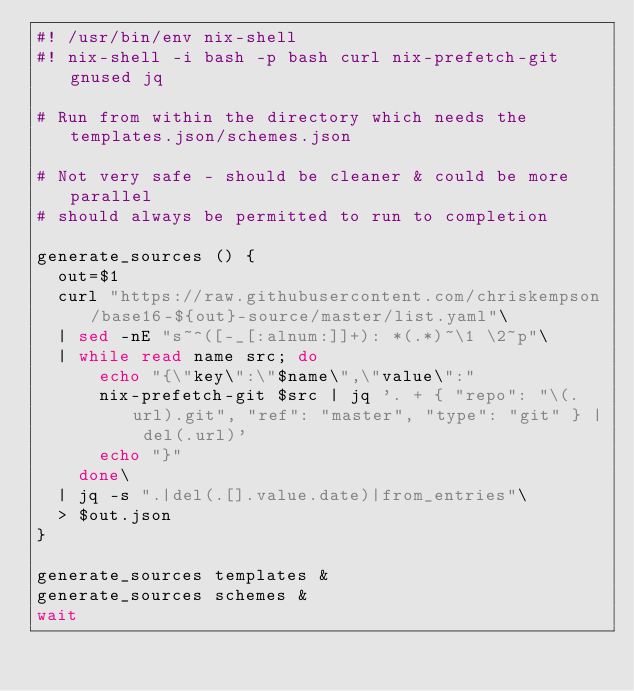Convert code to text. <code><loc_0><loc_0><loc_500><loc_500><_Bash_>#! /usr/bin/env nix-shell
#! nix-shell -i bash -p bash curl nix-prefetch-git gnused jq

# Run from within the directory which needs the templates.json/schemes.json

# Not very safe - should be cleaner & could be more parallel
# should always be permitted to run to completion

generate_sources () {
  out=$1
  curl "https://raw.githubusercontent.com/chriskempson/base16-${out}-source/master/list.yaml"\
  | sed -nE "s~^([-_[:alnum:]]+): *(.*)~\1 \2~p"\
  | while read name src; do
      echo "{\"key\":\"$name\",\"value\":"
      nix-prefetch-git $src | jq '. + { "repo": "\(.url).git", "ref": "master", "type": "git" } | del(.url)'
      echo "}"
    done\
  | jq -s ".|del(.[].value.date)|from_entries"\
  > $out.json
}

generate_sources templates &
generate_sources schemes &
wait
</code> 